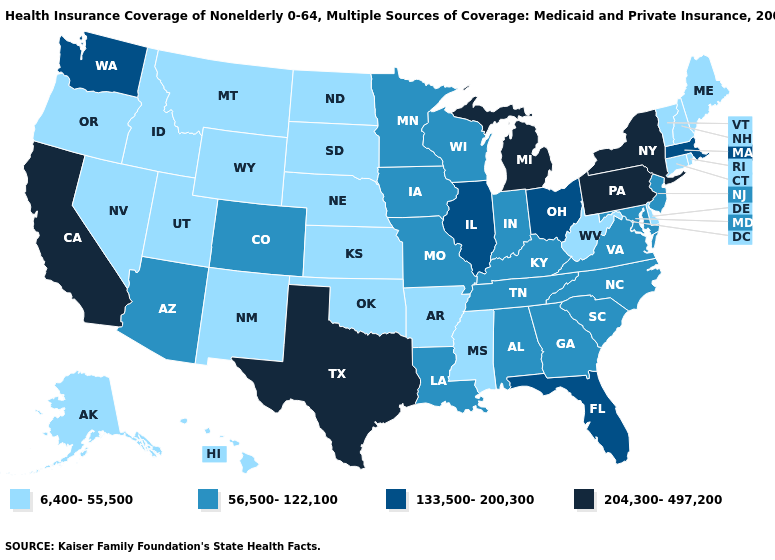Among the states that border Texas , which have the lowest value?
Give a very brief answer. Arkansas, New Mexico, Oklahoma. What is the lowest value in states that border Ohio?
Short answer required. 6,400-55,500. Does Tennessee have a lower value than Arizona?
Keep it brief. No. Name the states that have a value in the range 133,500-200,300?
Quick response, please. Florida, Illinois, Massachusetts, Ohio, Washington. Does Illinois have the same value as New Jersey?
Write a very short answer. No. Name the states that have a value in the range 56,500-122,100?
Give a very brief answer. Alabama, Arizona, Colorado, Georgia, Indiana, Iowa, Kentucky, Louisiana, Maryland, Minnesota, Missouri, New Jersey, North Carolina, South Carolina, Tennessee, Virginia, Wisconsin. Does Nevada have the highest value in the USA?
Short answer required. No. Which states hav the highest value in the West?
Write a very short answer. California. Does Texas have the highest value in the South?
Give a very brief answer. Yes. Which states have the highest value in the USA?
Short answer required. California, Michigan, New York, Pennsylvania, Texas. Among the states that border Vermont , does New York have the highest value?
Quick response, please. Yes. Name the states that have a value in the range 56,500-122,100?
Be succinct. Alabama, Arizona, Colorado, Georgia, Indiana, Iowa, Kentucky, Louisiana, Maryland, Minnesota, Missouri, New Jersey, North Carolina, South Carolina, Tennessee, Virginia, Wisconsin. Name the states that have a value in the range 133,500-200,300?
Answer briefly. Florida, Illinois, Massachusetts, Ohio, Washington. Name the states that have a value in the range 56,500-122,100?
Keep it brief. Alabama, Arizona, Colorado, Georgia, Indiana, Iowa, Kentucky, Louisiana, Maryland, Minnesota, Missouri, New Jersey, North Carolina, South Carolina, Tennessee, Virginia, Wisconsin. What is the value of Texas?
Write a very short answer. 204,300-497,200. 